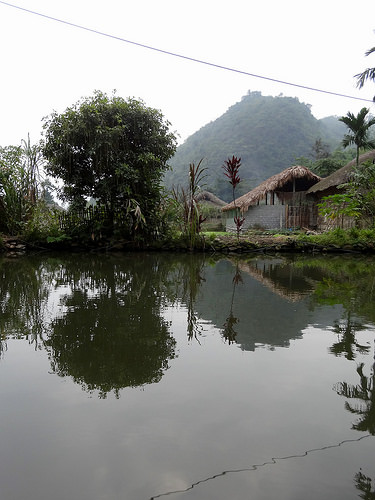<image>
Can you confirm if the rope shadow is on the water surface? Yes. Looking at the image, I can see the rope shadow is positioned on top of the water surface, with the water surface providing support. 